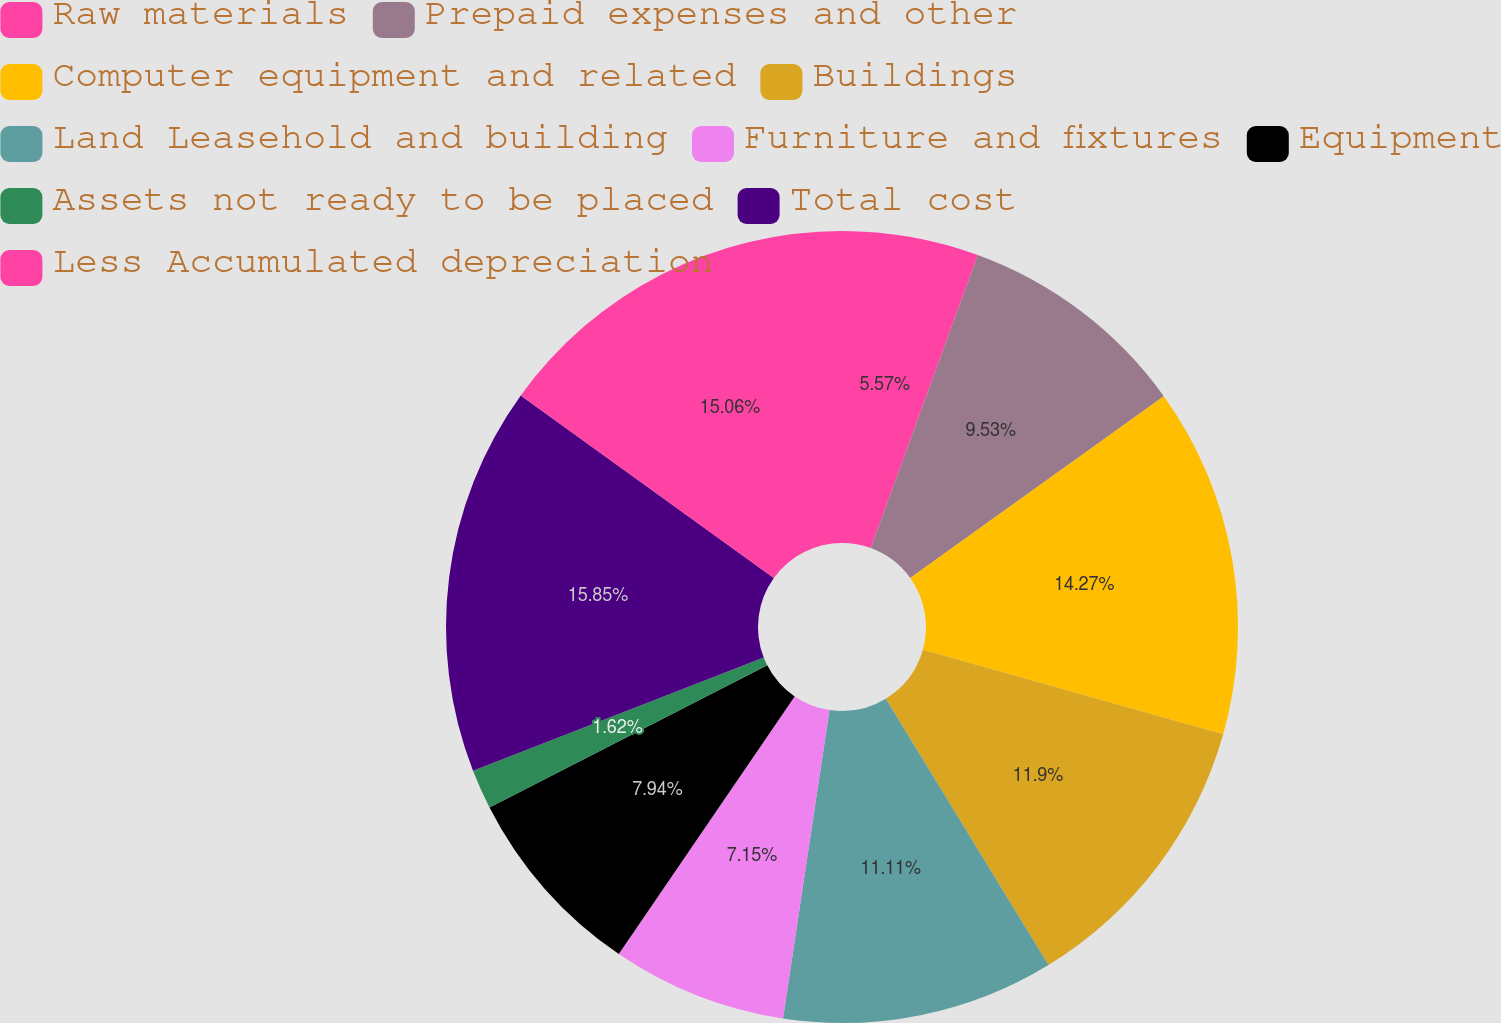Convert chart. <chart><loc_0><loc_0><loc_500><loc_500><pie_chart><fcel>Raw materials<fcel>Prepaid expenses and other<fcel>Computer equipment and related<fcel>Buildings<fcel>Land Leasehold and building<fcel>Furniture and fixtures<fcel>Equipment<fcel>Assets not ready to be placed<fcel>Total cost<fcel>Less Accumulated depreciation<nl><fcel>5.57%<fcel>9.53%<fcel>14.27%<fcel>11.9%<fcel>11.11%<fcel>7.15%<fcel>7.94%<fcel>1.62%<fcel>15.85%<fcel>15.06%<nl></chart> 